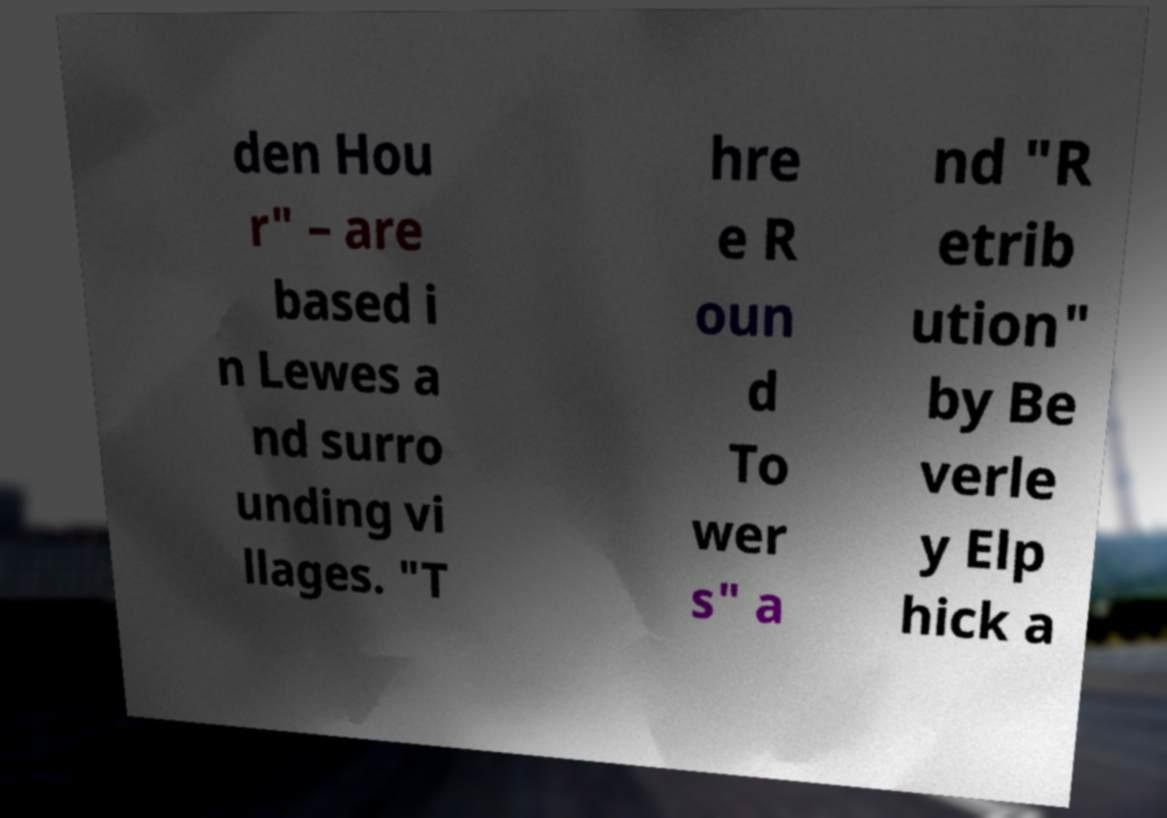There's text embedded in this image that I need extracted. Can you transcribe it verbatim? den Hou r" – are based i n Lewes a nd surro unding vi llages. "T hre e R oun d To wer s" a nd "R etrib ution" by Be verle y Elp hick a 